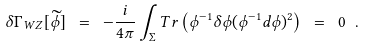<formula> <loc_0><loc_0><loc_500><loc_500>\delta \Gamma _ { W Z } [ \widetilde { \phi } ] \ = \ - \frac { i } { 4 \pi } \int _ { \Sigma } T r \left ( \phi ^ { - 1 } \delta \phi ( \phi ^ { - 1 } d \phi ) ^ { 2 } \right ) \ = \ 0 \ .</formula> 